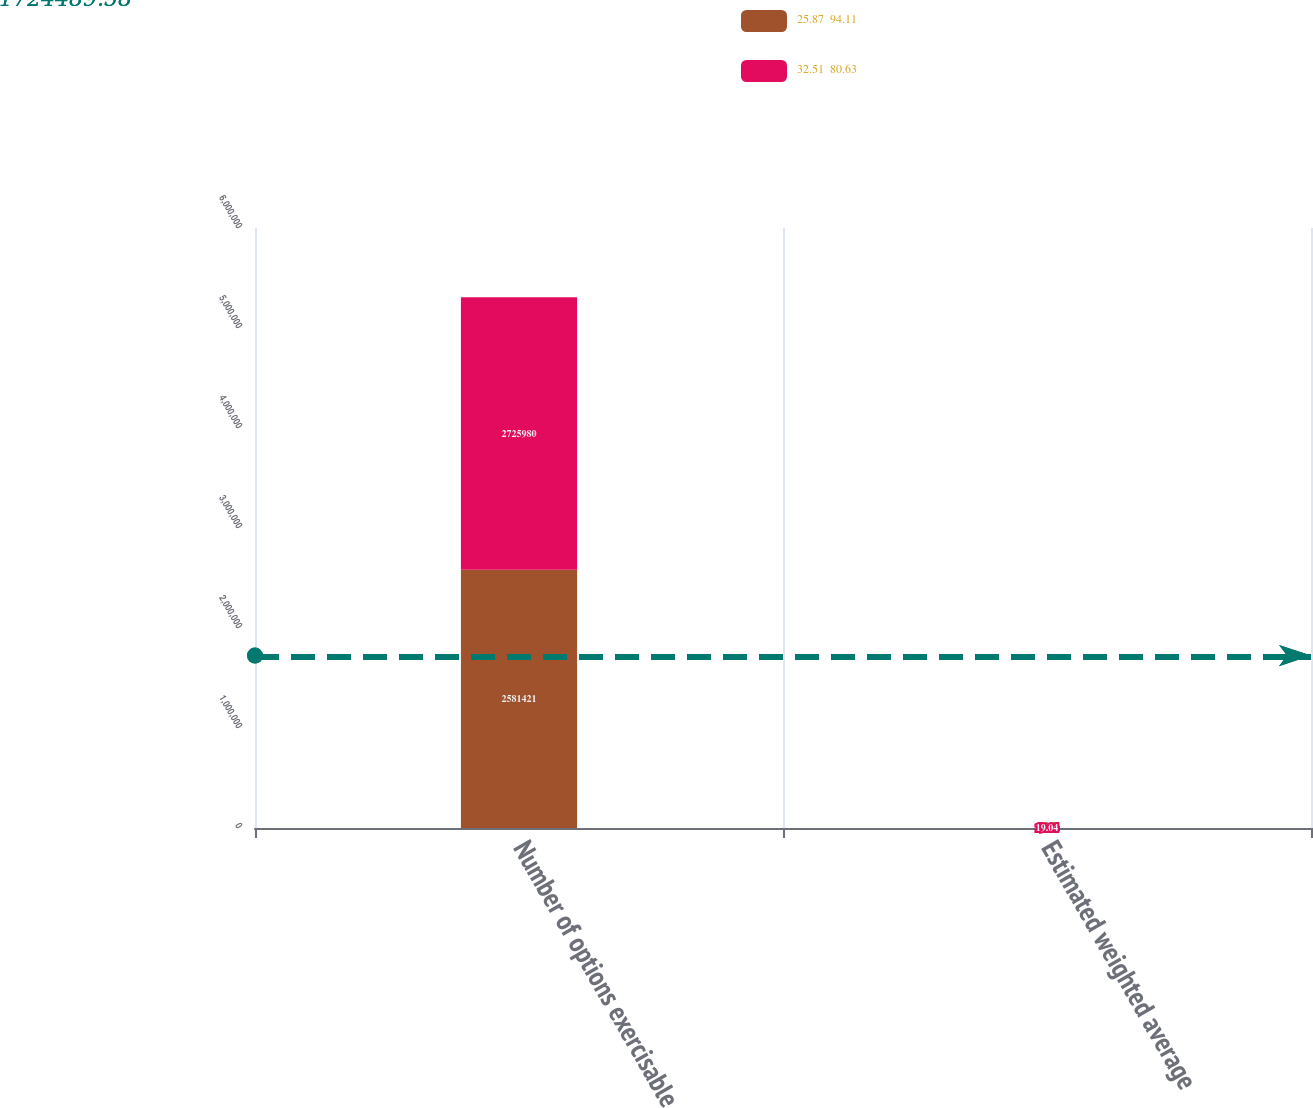<chart> <loc_0><loc_0><loc_500><loc_500><stacked_bar_chart><ecel><fcel>Number of options exercisable<fcel>Estimated weighted average<nl><fcel>25.87  94.11<fcel>2.58142e+06<fcel>12.8<nl><fcel>32.51  80.63<fcel>2.72598e+06<fcel>19.04<nl></chart> 